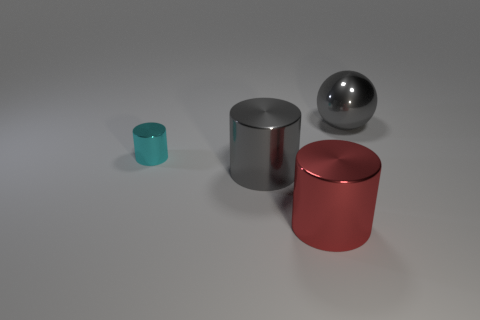Are there any other things that are the same size as the cyan object?
Make the answer very short. No. What material is the thing that is the same color as the shiny ball?
Provide a succinct answer. Metal. How many other things are there of the same color as the large metal sphere?
Ensure brevity in your answer.  1. Are there any other things that have the same shape as the red thing?
Ensure brevity in your answer.  Yes. Does the object behind the cyan object have the same size as the small cyan object?
Make the answer very short. No. How many metallic objects are either cyan cylinders or large gray balls?
Offer a terse response. 2. What size is the thing that is behind the small cyan metal object?
Provide a succinct answer. Large. Does the big red object have the same shape as the cyan metal object?
Your answer should be very brief. Yes. What number of tiny things are either shiny cylinders or gray cylinders?
Provide a short and direct response. 1. There is a cyan shiny cylinder; are there any gray shiny objects left of it?
Give a very brief answer. No. 